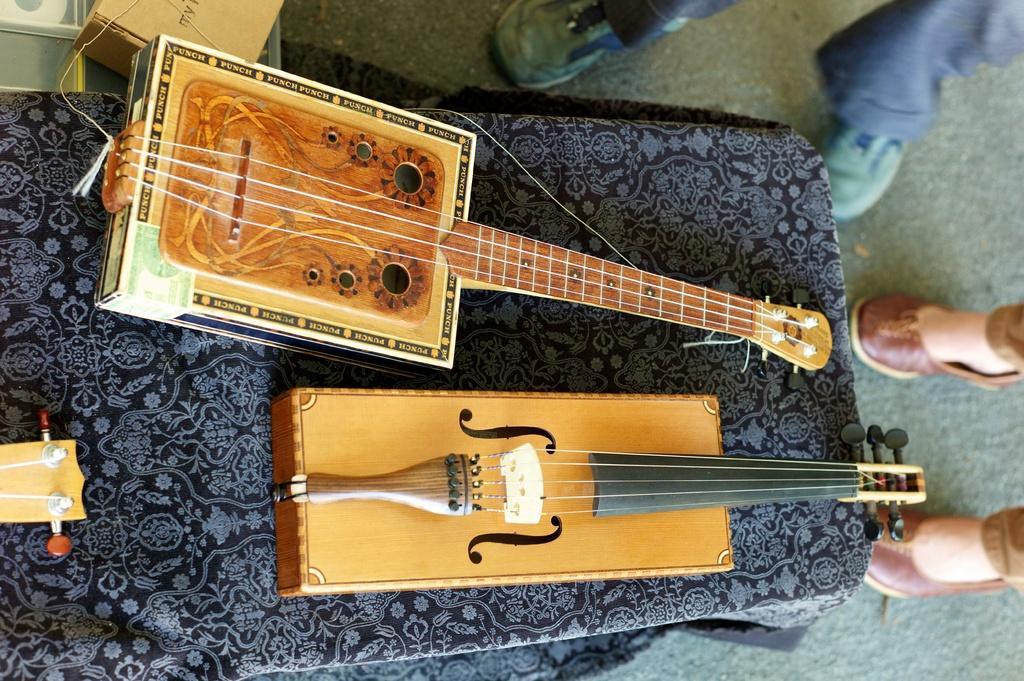Could you give a brief overview of what you see in this image? On this table there are guitars. Beside this table persons are standing. This is box. 